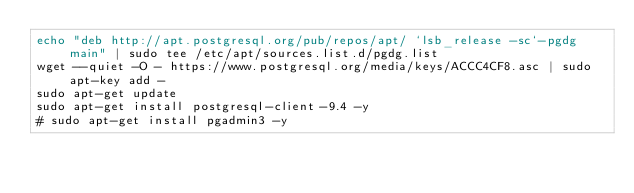Convert code to text. <code><loc_0><loc_0><loc_500><loc_500><_Bash_>echo "deb http://apt.postgresql.org/pub/repos/apt/ `lsb_release -sc`-pgdg main" | sudo tee /etc/apt/sources.list.d/pgdg.list
wget --quiet -O - https://www.postgresql.org/media/keys/ACCC4CF8.asc | sudo apt-key add -
sudo apt-get update
sudo apt-get install postgresql-client-9.4 -y
# sudo apt-get install pgadmin3 -y
</code> 